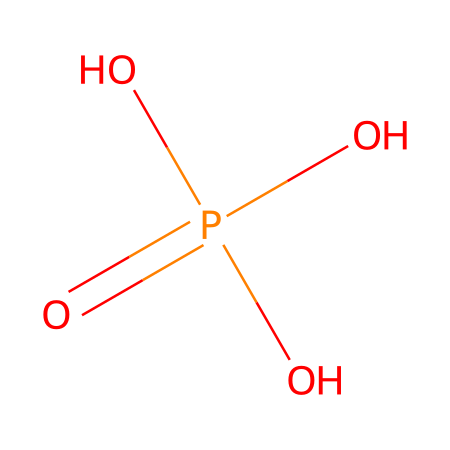What is the molecular formula of this compound? The SMILES representation indicates the presence of one phosphorus (P) atom and four oxygen (O) atoms. Therefore, the molecular formula can be derived directly from the atoms present.
Answer: H3PO4 How many hydroxyl (–OH) groups are present in this molecule? The chemical structure contains three –OH groups attached to the central phosphorus atom, indicating that there are three hydroxyl groups in the molecule.
Answer: 3 Which element is at the center of this structure? Upon analyzing the SMILES, phosphorus is shown to be the central atom linked to four oxygens, confirming its central role in this chemical structure.
Answer: phosphorus What is the oxidation state of phosphorus in this compound? The oxidation state of phosphorus can be determined from the overall formula (H3PO4). Here, phosphorus typically has an oxidation state of +5 when combined with oxygen in this context.
Answer: +5 Is this compound acidic or basic? Since phosphoric acid is noted for being a triprotic acid with the ability to donate three protons (H+), its acidic nature is established by its capacity to ionize in solution.
Answer: acidic What role does this compound play in cleaning audio equipment? Phosphoric acid is frequently utilized in cleaning agents due to its capability to remove stubborn corrosion and mineral deposits, making it effective for restoring audio equipment.
Answer: cleaning agent 